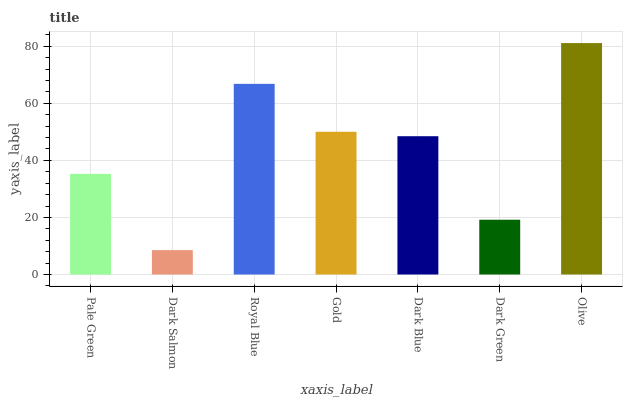Is Dark Salmon the minimum?
Answer yes or no. Yes. Is Olive the maximum?
Answer yes or no. Yes. Is Royal Blue the minimum?
Answer yes or no. No. Is Royal Blue the maximum?
Answer yes or no. No. Is Royal Blue greater than Dark Salmon?
Answer yes or no. Yes. Is Dark Salmon less than Royal Blue?
Answer yes or no. Yes. Is Dark Salmon greater than Royal Blue?
Answer yes or no. No. Is Royal Blue less than Dark Salmon?
Answer yes or no. No. Is Dark Blue the high median?
Answer yes or no. Yes. Is Dark Blue the low median?
Answer yes or no. Yes. Is Gold the high median?
Answer yes or no. No. Is Gold the low median?
Answer yes or no. No. 